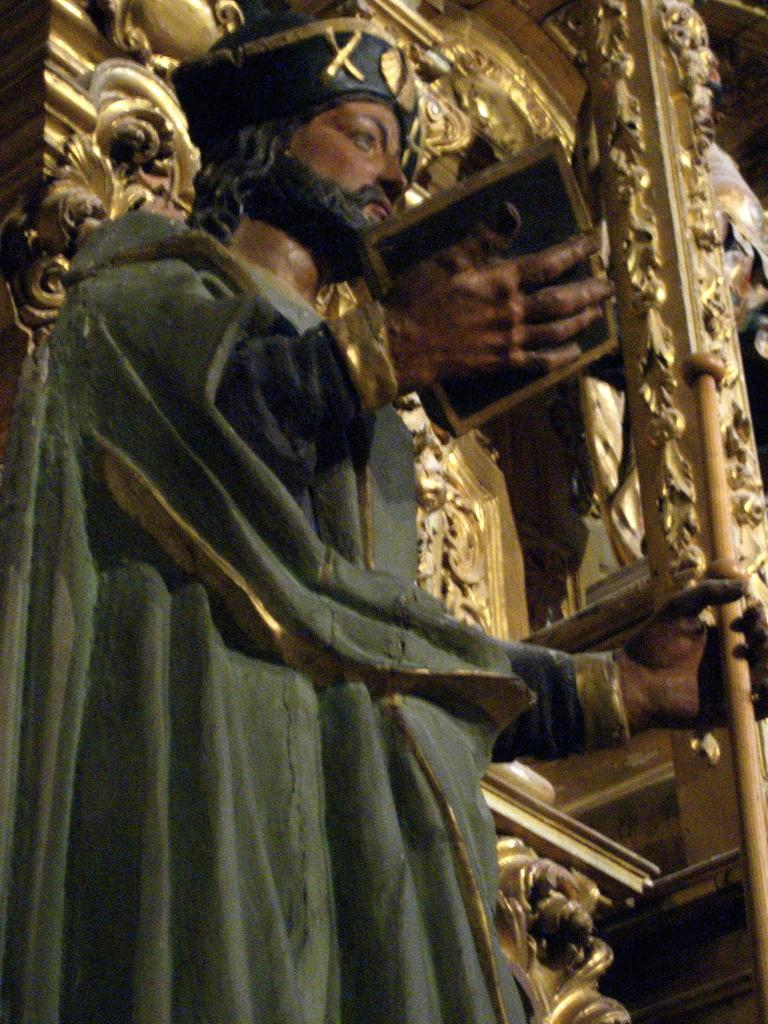What is the person in the image holding? The person in the image is holding a stick. What can be seen on the wall in the image? There are sculptures on the wall in the image. How many pizzas are being served by the person holding a stick in the image? There are no pizzas present in the image; the person is holding a stick and there are sculptures on the wall. 